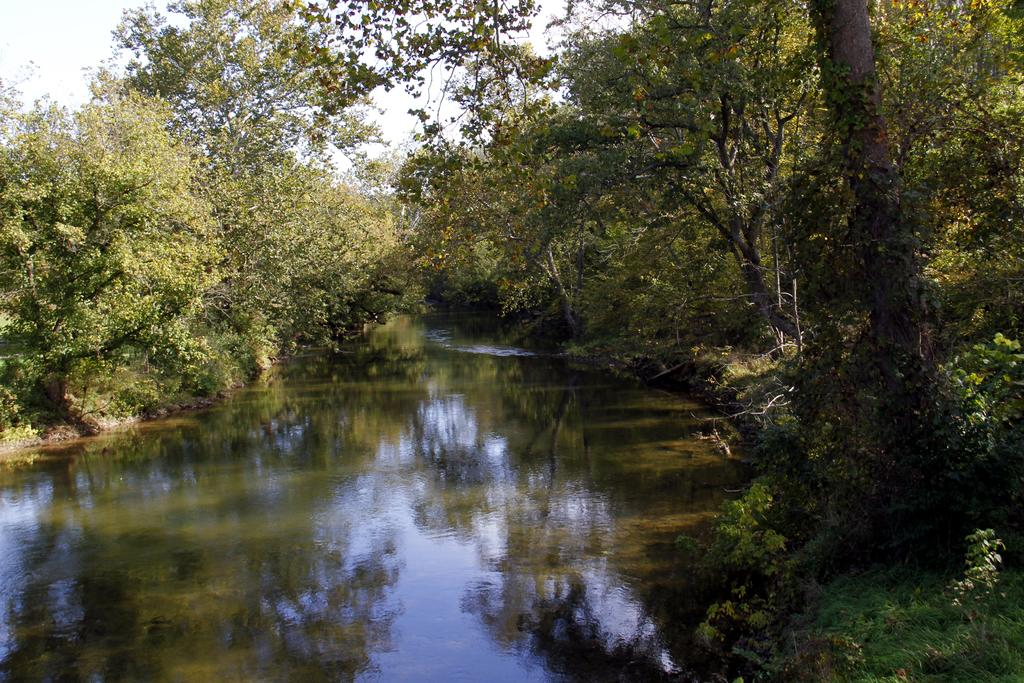What is the primary element in the picture? There is water in the picture. What type of vegetation can be seen in the picture? There are trees, plants, and grass in the picture. What is visible in the background of the picture? The sky is visible in the background of the picture. What type of cakes are being served at the expert's storytelling event in the picture? There is no expert, storytelling event, or cakes present in the image. 